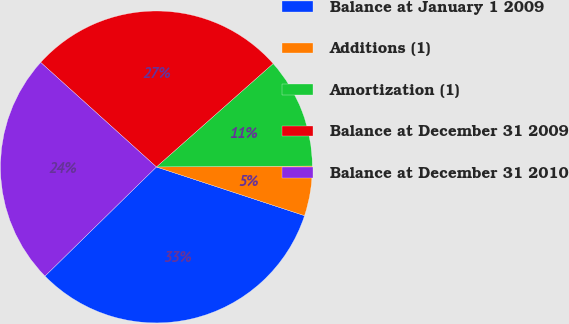Convert chart to OTSL. <chart><loc_0><loc_0><loc_500><loc_500><pie_chart><fcel>Balance at January 1 2009<fcel>Additions (1)<fcel>Amortization (1)<fcel>Balance at December 31 2009<fcel>Balance at December 31 2010<nl><fcel>32.61%<fcel>5.15%<fcel>11.44%<fcel>26.77%<fcel>24.03%<nl></chart> 